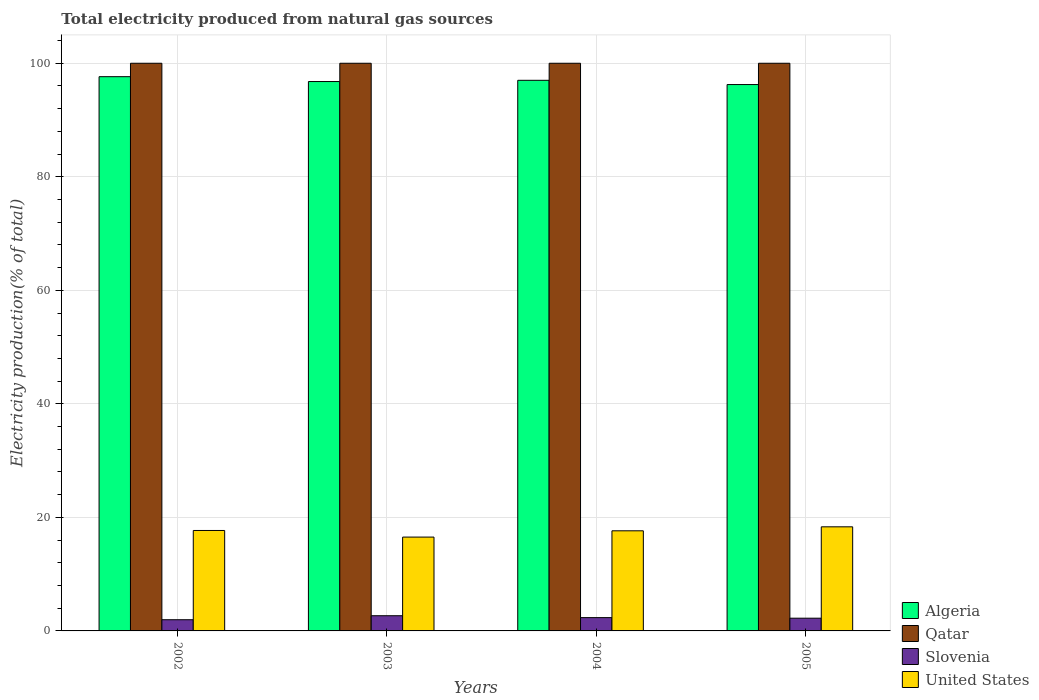How many different coloured bars are there?
Make the answer very short. 4. How many groups of bars are there?
Keep it short and to the point. 4. Are the number of bars on each tick of the X-axis equal?
Your answer should be compact. Yes. How many bars are there on the 3rd tick from the left?
Keep it short and to the point. 4. In how many cases, is the number of bars for a given year not equal to the number of legend labels?
Keep it short and to the point. 0. What is the total electricity produced in Qatar in 2002?
Offer a very short reply. 100. Across all years, what is the maximum total electricity produced in Algeria?
Provide a succinct answer. 97.63. Across all years, what is the minimum total electricity produced in Algeria?
Keep it short and to the point. 96.25. In which year was the total electricity produced in Qatar maximum?
Provide a succinct answer. 2002. In which year was the total electricity produced in Algeria minimum?
Provide a succinct answer. 2005. What is the total total electricity produced in United States in the graph?
Your response must be concise. 70.2. What is the difference between the total electricity produced in United States in 2003 and that in 2004?
Offer a very short reply. -1.11. What is the difference between the total electricity produced in United States in 2003 and the total electricity produced in Algeria in 2005?
Make the answer very short. -79.72. In the year 2003, what is the difference between the total electricity produced in Algeria and total electricity produced in United States?
Give a very brief answer. 80.25. In how many years, is the total electricity produced in Qatar greater than 76 %?
Your answer should be very brief. 4. What is the ratio of the total electricity produced in Slovenia in 2002 to that in 2004?
Your answer should be compact. 0.84. Is the total electricity produced in Qatar in 2003 less than that in 2005?
Your answer should be compact. No. Is the difference between the total electricity produced in Algeria in 2003 and 2004 greater than the difference between the total electricity produced in United States in 2003 and 2004?
Your answer should be very brief. Yes. What is the difference between the highest and the lowest total electricity produced in Slovenia?
Make the answer very short. 0.7. What does the 2nd bar from the right in 2003 represents?
Your answer should be compact. Slovenia. How many years are there in the graph?
Your answer should be compact. 4. What is the difference between two consecutive major ticks on the Y-axis?
Your answer should be compact. 20. Does the graph contain any zero values?
Offer a terse response. No. Where does the legend appear in the graph?
Your answer should be compact. Bottom right. What is the title of the graph?
Provide a short and direct response. Total electricity produced from natural gas sources. Does "Uruguay" appear as one of the legend labels in the graph?
Give a very brief answer. No. What is the label or title of the X-axis?
Ensure brevity in your answer.  Years. What is the Electricity production(% of total) in Algeria in 2002?
Make the answer very short. 97.63. What is the Electricity production(% of total) in Qatar in 2002?
Provide a succinct answer. 100. What is the Electricity production(% of total) of Slovenia in 2002?
Offer a very short reply. 1.97. What is the Electricity production(% of total) of United States in 2002?
Your answer should be very brief. 17.69. What is the Electricity production(% of total) in Algeria in 2003?
Your answer should be very brief. 96.78. What is the Electricity production(% of total) of Qatar in 2003?
Offer a very short reply. 100. What is the Electricity production(% of total) in Slovenia in 2003?
Your response must be concise. 2.68. What is the Electricity production(% of total) in United States in 2003?
Your answer should be compact. 16.53. What is the Electricity production(% of total) of Algeria in 2004?
Your answer should be compact. 97. What is the Electricity production(% of total) in Qatar in 2004?
Make the answer very short. 100. What is the Electricity production(% of total) in Slovenia in 2004?
Your answer should be compact. 2.34. What is the Electricity production(% of total) in United States in 2004?
Ensure brevity in your answer.  17.64. What is the Electricity production(% of total) of Algeria in 2005?
Your answer should be very brief. 96.25. What is the Electricity production(% of total) in Qatar in 2005?
Your response must be concise. 100. What is the Electricity production(% of total) in Slovenia in 2005?
Offer a terse response. 2.24. What is the Electricity production(% of total) in United States in 2005?
Your answer should be very brief. 18.34. Across all years, what is the maximum Electricity production(% of total) of Algeria?
Make the answer very short. 97.63. Across all years, what is the maximum Electricity production(% of total) of Slovenia?
Your response must be concise. 2.68. Across all years, what is the maximum Electricity production(% of total) of United States?
Offer a terse response. 18.34. Across all years, what is the minimum Electricity production(% of total) of Algeria?
Your answer should be very brief. 96.25. Across all years, what is the minimum Electricity production(% of total) of Qatar?
Offer a terse response. 100. Across all years, what is the minimum Electricity production(% of total) of Slovenia?
Give a very brief answer. 1.97. Across all years, what is the minimum Electricity production(% of total) in United States?
Make the answer very short. 16.53. What is the total Electricity production(% of total) in Algeria in the graph?
Your response must be concise. 387.66. What is the total Electricity production(% of total) of Qatar in the graph?
Provide a short and direct response. 400. What is the total Electricity production(% of total) of Slovenia in the graph?
Keep it short and to the point. 9.24. What is the total Electricity production(% of total) in United States in the graph?
Offer a very short reply. 70.2. What is the difference between the Electricity production(% of total) in Algeria in 2002 and that in 2003?
Your answer should be compact. 0.85. What is the difference between the Electricity production(% of total) in Qatar in 2002 and that in 2003?
Offer a very short reply. 0. What is the difference between the Electricity production(% of total) in Slovenia in 2002 and that in 2003?
Ensure brevity in your answer.  -0.7. What is the difference between the Electricity production(% of total) in United States in 2002 and that in 2003?
Give a very brief answer. 1.17. What is the difference between the Electricity production(% of total) in Algeria in 2002 and that in 2004?
Provide a short and direct response. 0.64. What is the difference between the Electricity production(% of total) of Qatar in 2002 and that in 2004?
Provide a succinct answer. 0. What is the difference between the Electricity production(% of total) of Slovenia in 2002 and that in 2004?
Offer a very short reply. -0.37. What is the difference between the Electricity production(% of total) of United States in 2002 and that in 2004?
Your response must be concise. 0.06. What is the difference between the Electricity production(% of total) of Algeria in 2002 and that in 2005?
Provide a succinct answer. 1.39. What is the difference between the Electricity production(% of total) of Slovenia in 2002 and that in 2005?
Your answer should be very brief. -0.27. What is the difference between the Electricity production(% of total) in United States in 2002 and that in 2005?
Provide a succinct answer. -0.64. What is the difference between the Electricity production(% of total) in Algeria in 2003 and that in 2004?
Your response must be concise. -0.22. What is the difference between the Electricity production(% of total) in Slovenia in 2003 and that in 2004?
Give a very brief answer. 0.33. What is the difference between the Electricity production(% of total) in United States in 2003 and that in 2004?
Your answer should be very brief. -1.11. What is the difference between the Electricity production(% of total) of Algeria in 2003 and that in 2005?
Your answer should be very brief. 0.53. What is the difference between the Electricity production(% of total) of Qatar in 2003 and that in 2005?
Provide a succinct answer. 0. What is the difference between the Electricity production(% of total) in Slovenia in 2003 and that in 2005?
Make the answer very short. 0.43. What is the difference between the Electricity production(% of total) of United States in 2003 and that in 2005?
Provide a succinct answer. -1.81. What is the difference between the Electricity production(% of total) of Algeria in 2004 and that in 2005?
Keep it short and to the point. 0.75. What is the difference between the Electricity production(% of total) of Slovenia in 2004 and that in 2005?
Keep it short and to the point. 0.1. What is the difference between the Electricity production(% of total) of United States in 2004 and that in 2005?
Make the answer very short. -0.7. What is the difference between the Electricity production(% of total) in Algeria in 2002 and the Electricity production(% of total) in Qatar in 2003?
Make the answer very short. -2.37. What is the difference between the Electricity production(% of total) in Algeria in 2002 and the Electricity production(% of total) in Slovenia in 2003?
Keep it short and to the point. 94.96. What is the difference between the Electricity production(% of total) in Algeria in 2002 and the Electricity production(% of total) in United States in 2003?
Offer a terse response. 81.11. What is the difference between the Electricity production(% of total) of Qatar in 2002 and the Electricity production(% of total) of Slovenia in 2003?
Offer a very short reply. 97.32. What is the difference between the Electricity production(% of total) in Qatar in 2002 and the Electricity production(% of total) in United States in 2003?
Provide a short and direct response. 83.47. What is the difference between the Electricity production(% of total) of Slovenia in 2002 and the Electricity production(% of total) of United States in 2003?
Your answer should be very brief. -14.56. What is the difference between the Electricity production(% of total) in Algeria in 2002 and the Electricity production(% of total) in Qatar in 2004?
Offer a terse response. -2.37. What is the difference between the Electricity production(% of total) of Algeria in 2002 and the Electricity production(% of total) of Slovenia in 2004?
Make the answer very short. 95.29. What is the difference between the Electricity production(% of total) of Algeria in 2002 and the Electricity production(% of total) of United States in 2004?
Give a very brief answer. 80. What is the difference between the Electricity production(% of total) in Qatar in 2002 and the Electricity production(% of total) in Slovenia in 2004?
Offer a terse response. 97.66. What is the difference between the Electricity production(% of total) in Qatar in 2002 and the Electricity production(% of total) in United States in 2004?
Provide a succinct answer. 82.36. What is the difference between the Electricity production(% of total) in Slovenia in 2002 and the Electricity production(% of total) in United States in 2004?
Your answer should be compact. -15.66. What is the difference between the Electricity production(% of total) of Algeria in 2002 and the Electricity production(% of total) of Qatar in 2005?
Your response must be concise. -2.37. What is the difference between the Electricity production(% of total) of Algeria in 2002 and the Electricity production(% of total) of Slovenia in 2005?
Your answer should be compact. 95.39. What is the difference between the Electricity production(% of total) in Algeria in 2002 and the Electricity production(% of total) in United States in 2005?
Offer a terse response. 79.3. What is the difference between the Electricity production(% of total) in Qatar in 2002 and the Electricity production(% of total) in Slovenia in 2005?
Give a very brief answer. 97.76. What is the difference between the Electricity production(% of total) of Qatar in 2002 and the Electricity production(% of total) of United States in 2005?
Make the answer very short. 81.66. What is the difference between the Electricity production(% of total) of Slovenia in 2002 and the Electricity production(% of total) of United States in 2005?
Provide a succinct answer. -16.37. What is the difference between the Electricity production(% of total) in Algeria in 2003 and the Electricity production(% of total) in Qatar in 2004?
Make the answer very short. -3.22. What is the difference between the Electricity production(% of total) of Algeria in 2003 and the Electricity production(% of total) of Slovenia in 2004?
Keep it short and to the point. 94.44. What is the difference between the Electricity production(% of total) of Algeria in 2003 and the Electricity production(% of total) of United States in 2004?
Your answer should be compact. 79.14. What is the difference between the Electricity production(% of total) of Qatar in 2003 and the Electricity production(% of total) of Slovenia in 2004?
Provide a short and direct response. 97.66. What is the difference between the Electricity production(% of total) of Qatar in 2003 and the Electricity production(% of total) of United States in 2004?
Give a very brief answer. 82.36. What is the difference between the Electricity production(% of total) in Slovenia in 2003 and the Electricity production(% of total) in United States in 2004?
Your answer should be very brief. -14.96. What is the difference between the Electricity production(% of total) of Algeria in 2003 and the Electricity production(% of total) of Qatar in 2005?
Keep it short and to the point. -3.22. What is the difference between the Electricity production(% of total) of Algeria in 2003 and the Electricity production(% of total) of Slovenia in 2005?
Provide a short and direct response. 94.54. What is the difference between the Electricity production(% of total) of Algeria in 2003 and the Electricity production(% of total) of United States in 2005?
Give a very brief answer. 78.44. What is the difference between the Electricity production(% of total) of Qatar in 2003 and the Electricity production(% of total) of Slovenia in 2005?
Offer a very short reply. 97.76. What is the difference between the Electricity production(% of total) of Qatar in 2003 and the Electricity production(% of total) of United States in 2005?
Give a very brief answer. 81.66. What is the difference between the Electricity production(% of total) of Slovenia in 2003 and the Electricity production(% of total) of United States in 2005?
Your answer should be very brief. -15.66. What is the difference between the Electricity production(% of total) in Algeria in 2004 and the Electricity production(% of total) in Qatar in 2005?
Provide a short and direct response. -3. What is the difference between the Electricity production(% of total) of Algeria in 2004 and the Electricity production(% of total) of Slovenia in 2005?
Make the answer very short. 94.76. What is the difference between the Electricity production(% of total) in Algeria in 2004 and the Electricity production(% of total) in United States in 2005?
Make the answer very short. 78.66. What is the difference between the Electricity production(% of total) of Qatar in 2004 and the Electricity production(% of total) of Slovenia in 2005?
Give a very brief answer. 97.76. What is the difference between the Electricity production(% of total) of Qatar in 2004 and the Electricity production(% of total) of United States in 2005?
Offer a terse response. 81.66. What is the difference between the Electricity production(% of total) of Slovenia in 2004 and the Electricity production(% of total) of United States in 2005?
Offer a terse response. -15.99. What is the average Electricity production(% of total) in Algeria per year?
Make the answer very short. 96.92. What is the average Electricity production(% of total) in Slovenia per year?
Your answer should be very brief. 2.31. What is the average Electricity production(% of total) of United States per year?
Make the answer very short. 17.55. In the year 2002, what is the difference between the Electricity production(% of total) of Algeria and Electricity production(% of total) of Qatar?
Give a very brief answer. -2.37. In the year 2002, what is the difference between the Electricity production(% of total) in Algeria and Electricity production(% of total) in Slovenia?
Provide a succinct answer. 95.66. In the year 2002, what is the difference between the Electricity production(% of total) in Algeria and Electricity production(% of total) in United States?
Your answer should be compact. 79.94. In the year 2002, what is the difference between the Electricity production(% of total) in Qatar and Electricity production(% of total) in Slovenia?
Ensure brevity in your answer.  98.03. In the year 2002, what is the difference between the Electricity production(% of total) in Qatar and Electricity production(% of total) in United States?
Offer a terse response. 82.31. In the year 2002, what is the difference between the Electricity production(% of total) of Slovenia and Electricity production(% of total) of United States?
Your response must be concise. -15.72. In the year 2003, what is the difference between the Electricity production(% of total) in Algeria and Electricity production(% of total) in Qatar?
Make the answer very short. -3.22. In the year 2003, what is the difference between the Electricity production(% of total) in Algeria and Electricity production(% of total) in Slovenia?
Provide a short and direct response. 94.1. In the year 2003, what is the difference between the Electricity production(% of total) of Algeria and Electricity production(% of total) of United States?
Your answer should be compact. 80.25. In the year 2003, what is the difference between the Electricity production(% of total) in Qatar and Electricity production(% of total) in Slovenia?
Offer a terse response. 97.32. In the year 2003, what is the difference between the Electricity production(% of total) in Qatar and Electricity production(% of total) in United States?
Offer a terse response. 83.47. In the year 2003, what is the difference between the Electricity production(% of total) in Slovenia and Electricity production(% of total) in United States?
Make the answer very short. -13.85. In the year 2004, what is the difference between the Electricity production(% of total) of Algeria and Electricity production(% of total) of Qatar?
Your response must be concise. -3. In the year 2004, what is the difference between the Electricity production(% of total) of Algeria and Electricity production(% of total) of Slovenia?
Give a very brief answer. 94.65. In the year 2004, what is the difference between the Electricity production(% of total) in Algeria and Electricity production(% of total) in United States?
Offer a terse response. 79.36. In the year 2004, what is the difference between the Electricity production(% of total) of Qatar and Electricity production(% of total) of Slovenia?
Give a very brief answer. 97.66. In the year 2004, what is the difference between the Electricity production(% of total) in Qatar and Electricity production(% of total) in United States?
Your response must be concise. 82.36. In the year 2004, what is the difference between the Electricity production(% of total) in Slovenia and Electricity production(% of total) in United States?
Give a very brief answer. -15.29. In the year 2005, what is the difference between the Electricity production(% of total) of Algeria and Electricity production(% of total) of Qatar?
Provide a succinct answer. -3.75. In the year 2005, what is the difference between the Electricity production(% of total) in Algeria and Electricity production(% of total) in Slovenia?
Provide a succinct answer. 94.01. In the year 2005, what is the difference between the Electricity production(% of total) of Algeria and Electricity production(% of total) of United States?
Offer a very short reply. 77.91. In the year 2005, what is the difference between the Electricity production(% of total) in Qatar and Electricity production(% of total) in Slovenia?
Make the answer very short. 97.76. In the year 2005, what is the difference between the Electricity production(% of total) of Qatar and Electricity production(% of total) of United States?
Keep it short and to the point. 81.66. In the year 2005, what is the difference between the Electricity production(% of total) in Slovenia and Electricity production(% of total) in United States?
Provide a short and direct response. -16.1. What is the ratio of the Electricity production(% of total) in Algeria in 2002 to that in 2003?
Provide a short and direct response. 1.01. What is the ratio of the Electricity production(% of total) in Qatar in 2002 to that in 2003?
Provide a succinct answer. 1. What is the ratio of the Electricity production(% of total) in Slovenia in 2002 to that in 2003?
Keep it short and to the point. 0.74. What is the ratio of the Electricity production(% of total) in United States in 2002 to that in 2003?
Provide a succinct answer. 1.07. What is the ratio of the Electricity production(% of total) in Algeria in 2002 to that in 2004?
Make the answer very short. 1.01. What is the ratio of the Electricity production(% of total) in Qatar in 2002 to that in 2004?
Your answer should be compact. 1. What is the ratio of the Electricity production(% of total) of Slovenia in 2002 to that in 2004?
Provide a short and direct response. 0.84. What is the ratio of the Electricity production(% of total) of Algeria in 2002 to that in 2005?
Make the answer very short. 1.01. What is the ratio of the Electricity production(% of total) of Slovenia in 2002 to that in 2005?
Your answer should be very brief. 0.88. What is the ratio of the Electricity production(% of total) of United States in 2002 to that in 2005?
Your answer should be very brief. 0.96. What is the ratio of the Electricity production(% of total) in Algeria in 2003 to that in 2004?
Your answer should be compact. 1. What is the ratio of the Electricity production(% of total) in Qatar in 2003 to that in 2004?
Make the answer very short. 1. What is the ratio of the Electricity production(% of total) of Slovenia in 2003 to that in 2004?
Give a very brief answer. 1.14. What is the ratio of the Electricity production(% of total) in United States in 2003 to that in 2004?
Offer a very short reply. 0.94. What is the ratio of the Electricity production(% of total) in Algeria in 2003 to that in 2005?
Ensure brevity in your answer.  1.01. What is the ratio of the Electricity production(% of total) of Qatar in 2003 to that in 2005?
Offer a terse response. 1. What is the ratio of the Electricity production(% of total) in Slovenia in 2003 to that in 2005?
Provide a short and direct response. 1.19. What is the ratio of the Electricity production(% of total) in United States in 2003 to that in 2005?
Give a very brief answer. 0.9. What is the ratio of the Electricity production(% of total) of Qatar in 2004 to that in 2005?
Your answer should be very brief. 1. What is the ratio of the Electricity production(% of total) of Slovenia in 2004 to that in 2005?
Provide a short and direct response. 1.05. What is the ratio of the Electricity production(% of total) of United States in 2004 to that in 2005?
Give a very brief answer. 0.96. What is the difference between the highest and the second highest Electricity production(% of total) of Algeria?
Provide a succinct answer. 0.64. What is the difference between the highest and the second highest Electricity production(% of total) of Qatar?
Your answer should be compact. 0. What is the difference between the highest and the second highest Electricity production(% of total) in Slovenia?
Your response must be concise. 0.33. What is the difference between the highest and the second highest Electricity production(% of total) of United States?
Provide a short and direct response. 0.64. What is the difference between the highest and the lowest Electricity production(% of total) of Algeria?
Keep it short and to the point. 1.39. What is the difference between the highest and the lowest Electricity production(% of total) in Qatar?
Keep it short and to the point. 0. What is the difference between the highest and the lowest Electricity production(% of total) in Slovenia?
Provide a short and direct response. 0.7. What is the difference between the highest and the lowest Electricity production(% of total) in United States?
Offer a very short reply. 1.81. 